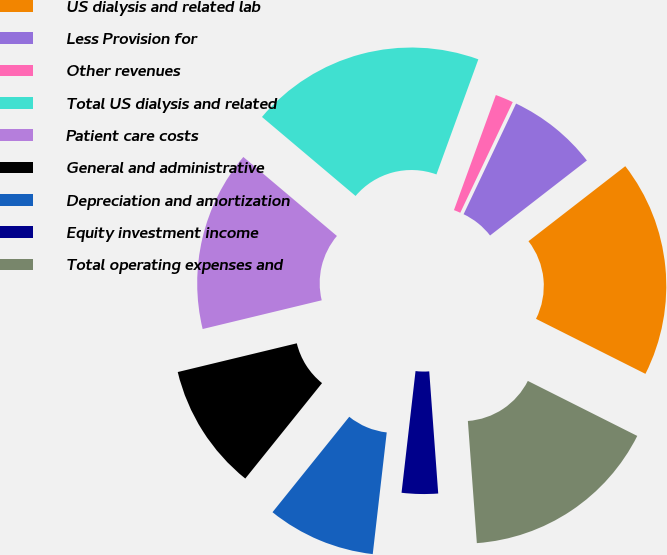<chart> <loc_0><loc_0><loc_500><loc_500><pie_chart><fcel>US dialysis and related lab<fcel>Less Provision for<fcel>Other revenues<fcel>Total US dialysis and related<fcel>Patient care costs<fcel>General and administrative<fcel>Depreciation and amortization<fcel>Equity investment income<fcel>Total operating expenses and<nl><fcel>17.91%<fcel>7.46%<fcel>1.49%<fcel>19.4%<fcel>14.93%<fcel>10.45%<fcel>8.96%<fcel>2.99%<fcel>16.42%<nl></chart> 